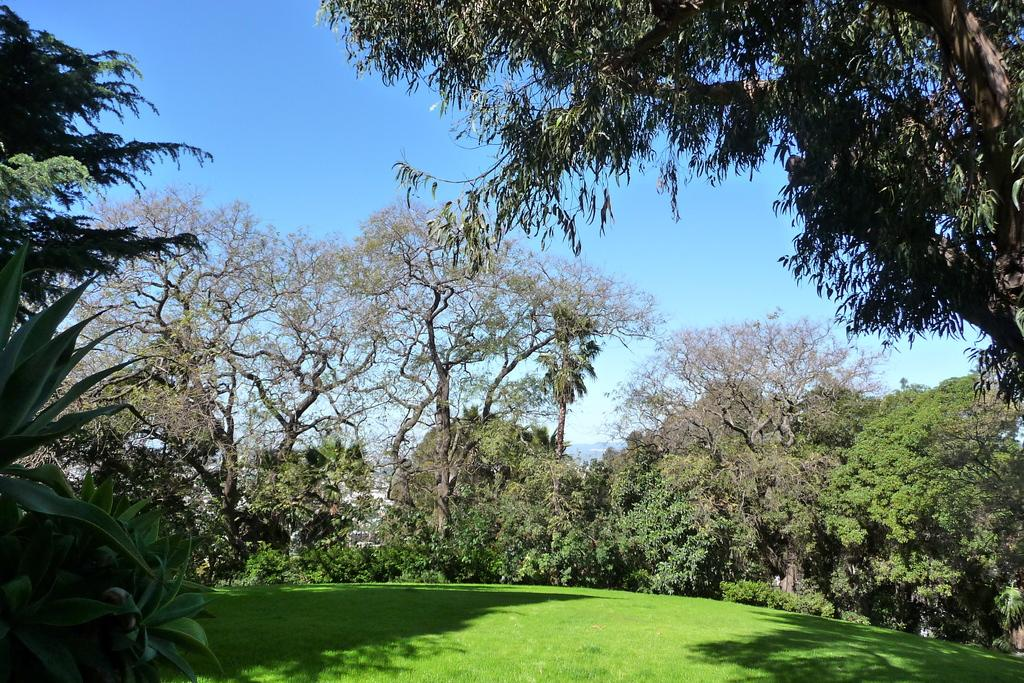What type of vegetation is present in the image? There are many trees, plants, and grass in the image. What can be seen in the background of the image? There are buildings in the background of the image. What is visible at the top of the image? The sky is visible at the top of the image. How much honey can be seen dripping from the trees in the image? There is no honey present in the image; it features trees, plants, grass, buildings, and the sky. 